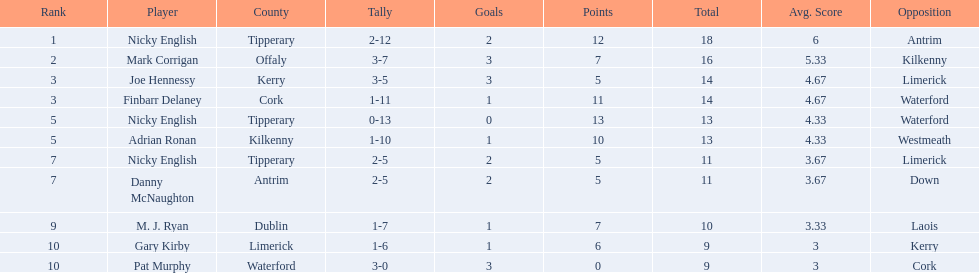What numbers are in the total column? 18, 16, 14, 14, 13, 13, 11, 11, 10, 9, 9. What row has the number 10 in the total column? 9, M. J. Ryan, Dublin, 1-7, 10, Laois. What name is in the player column for this row? M. J. Ryan. 